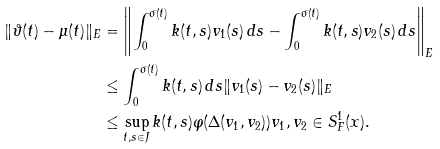<formula> <loc_0><loc_0><loc_500><loc_500>\| \vartheta ( t ) - \mu ( t ) \| _ { E } & = \left \| \int _ { 0 } ^ { \sigma ( t ) } k ( t , s ) v _ { 1 } ( s ) \, d s - \int _ { 0 } ^ { \sigma ( t ) } k ( t , s ) v _ { 2 } ( s ) \, d s \right \| _ { E } \\ & \leq \int _ { 0 } ^ { \sigma ( t ) } k ( t , s ) \, d s \| v _ { 1 } ( s ) - v _ { 2 } ( s ) \| _ { E } \\ & \leq \sup _ { t , s \in J } k ( t , s ) \varphi ( \Delta ( v _ { 1 } , v _ { 2 } ) ) v _ { 1 } , v _ { 2 } \in S ^ { 1 } _ { F } ( x ) .</formula> 